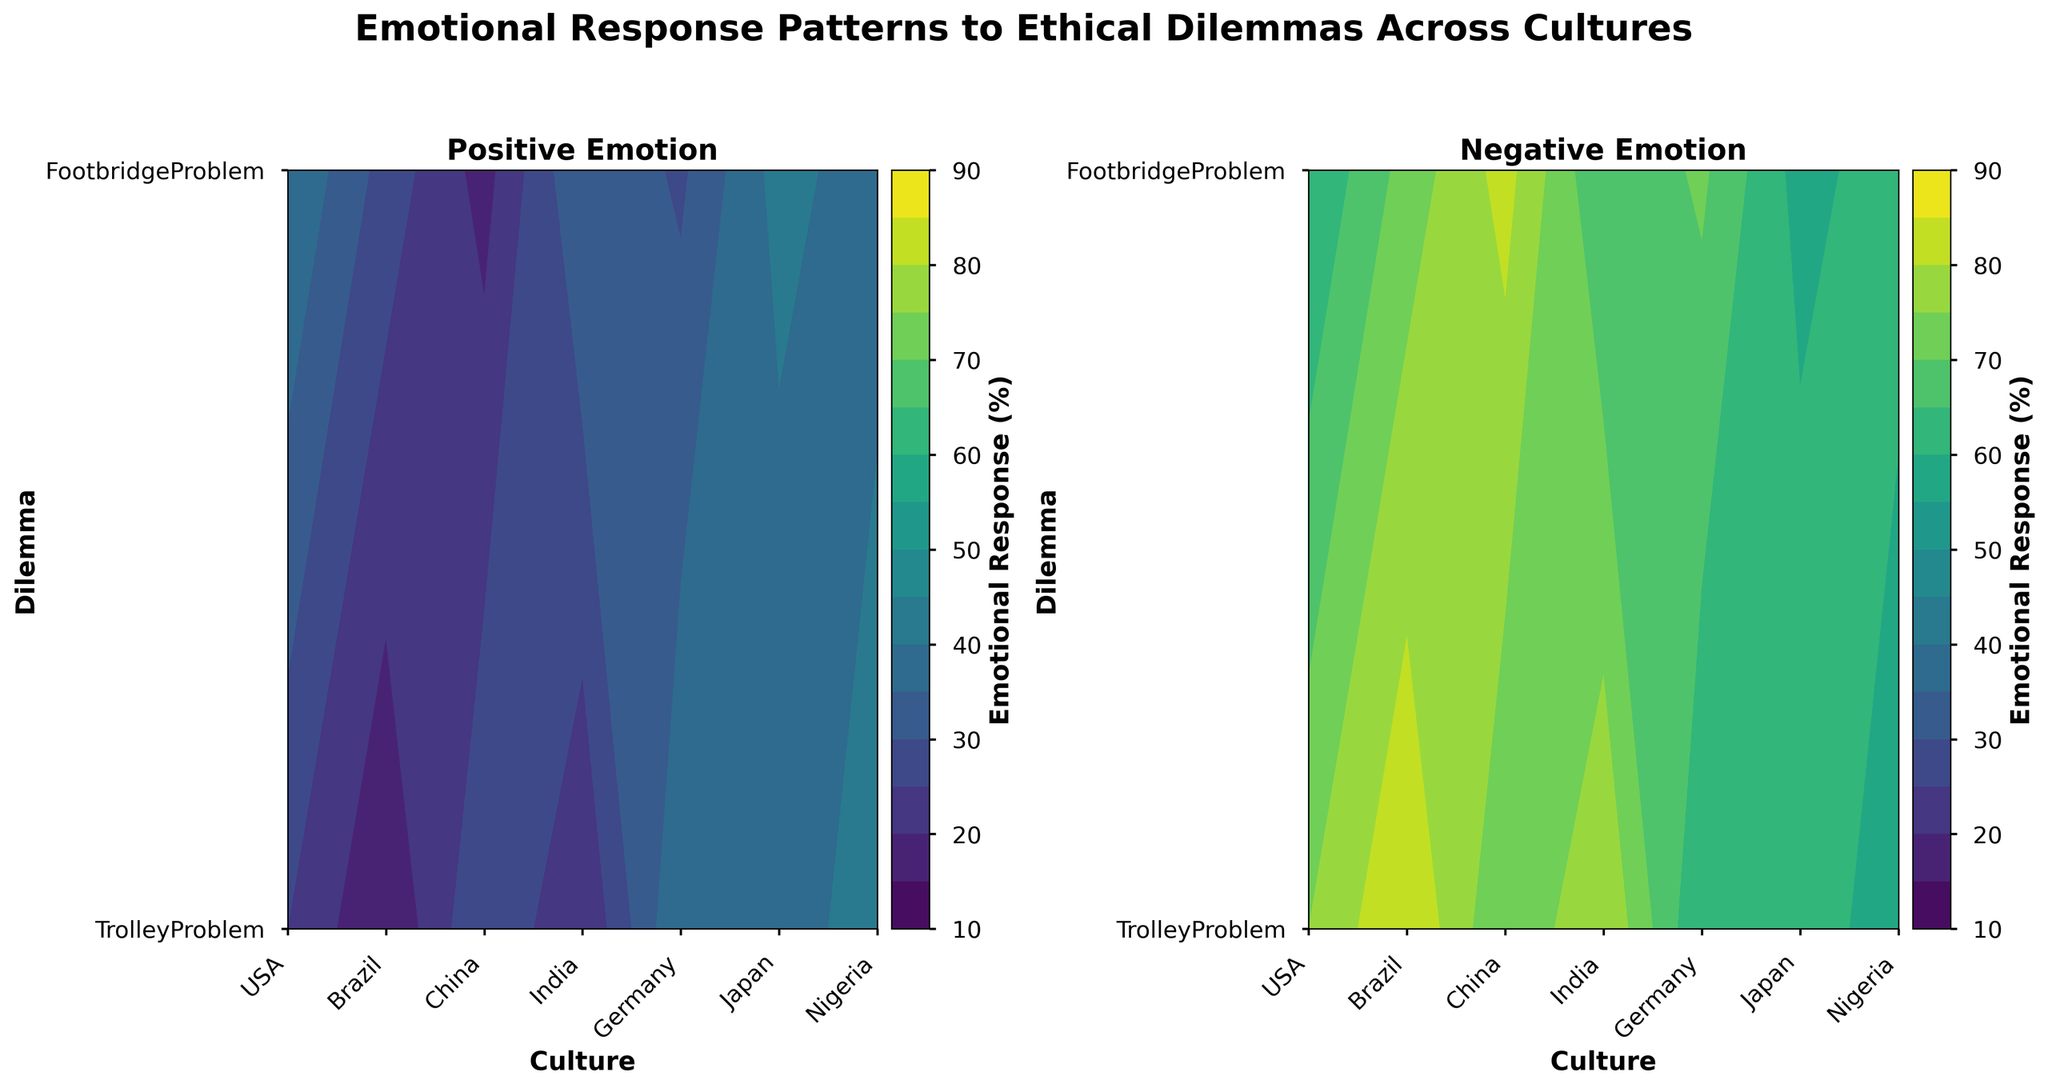What is the title of the figure? The title is written at the top center of the figure in bold and large font. It summarizes the main topic of the plot.
Answer: Emotional Response Patterns to Ethical Dilemmas Across Cultures What are the two types of emotional responses shown in the figure? The titles for the subplots are at the top of each contour plot. One on the left and one on the right.
Answer: Positive Emotion, Negative Emotion Which culture has the highest percentage of positive emotion in response to the Footbridge Problem? Look at the contour plot for Positive Emotion, find the y-axis label for Footbridge Problem, and see which culture (x-axis label) has the highest contour level.
Answer: India How does the positive emotional response to the Trolley Problem in China compare to the positive emotional response to the Footbridge Problem in Japan? Find the positive emotion values for China and Japan at the respective dilemma labels on the y-axis and compare them.
Answer: China's response is higher (40% vs 29%) What is the average positive emotional response for the Footbridge Problem across all cultures? Find positive emotion values for the Footbridge Problem across all cultures, sum them, and divide by the number of values. (15+20+35+40+18+29+37)/7 = 27.71%
Answer: 27.71% Which dilemma generally elicits a stronger negative emotional response across all cultures? Compare the overall color intensity of the negative emotion contour plots for both dilemmas.
Answer: Footbridge Problem In which culture does the Trolley Problem elicit a higher positive emotional response compared to the negative emotional response? Find the corresponding values for the USA, Brazil, China, India, Germany, Japan, Nigeria in both positive and negative emotion plots for the Trolley Problem. Compare for each culture.
Answer: None Which culture has the smallest difference in positive emotional response between the Trolley Problem and the Footbridge Problem? Calculate the differences for each culture and identify the smallest one.
Answer: Germany (28% - 18% = 10%) What is the contour level range used in both positive and negative emotional response plots? Identify the range of levels used in both plots by observing the color bars on the right side of each contour plot.
Answer: 10% to 90% Which culture shows a higher positive emotional response in the Trolley Problem compared to the average positive emotional response for the Footbridge Problem? Calculate the average positive emotional response for the Footbridge Problem and compare it with the Trolley Problem value for each culture.
Answer: China, India, Nigeria 